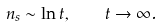<formula> <loc_0><loc_0><loc_500><loc_500>n _ { s } \sim \ln t , \quad t \to \infty .</formula> 